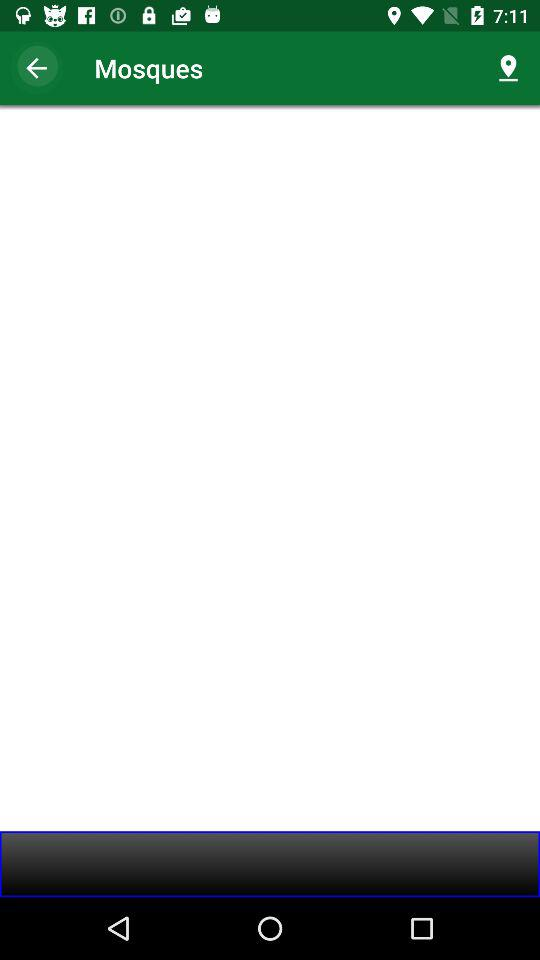How many prayer times are there?
Answer the question using a single word or phrase. 5 